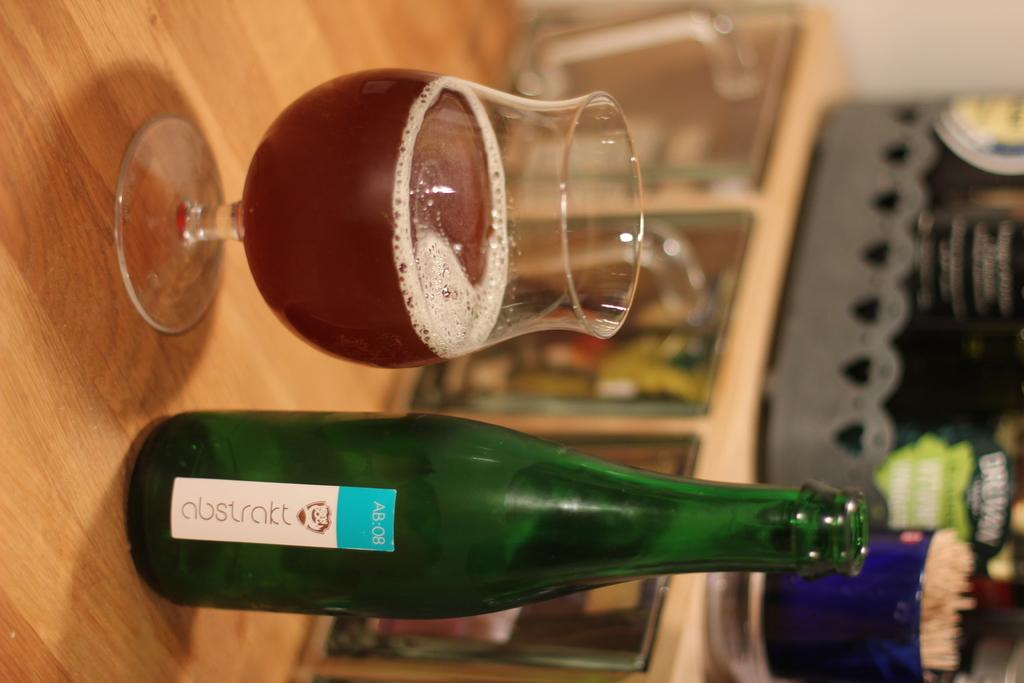<image>
Describe the image concisely. A bottle of liquor next to a full glass totled abstrakt 